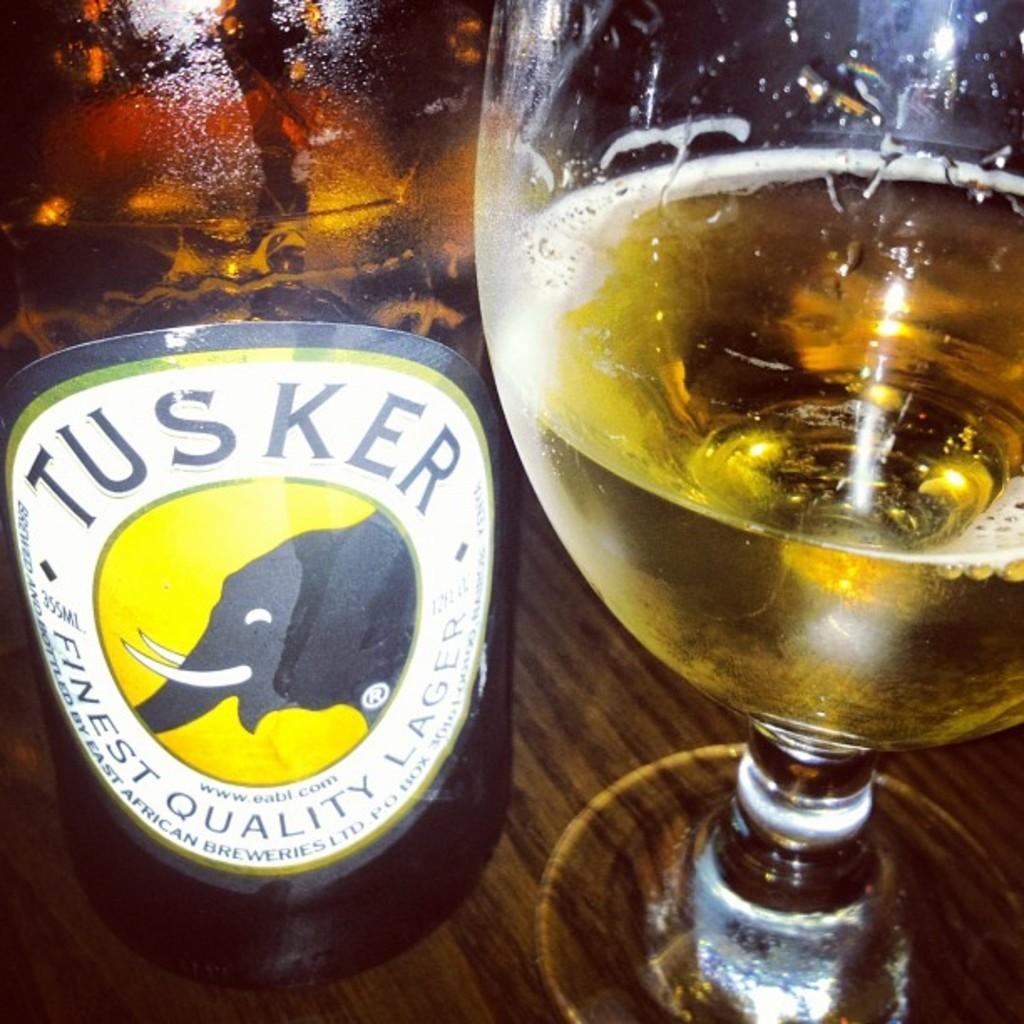Provide a one-sentence caption for the provided image. A bottle of Tusker is sitting next to a partially drank glass of beer on a table. 